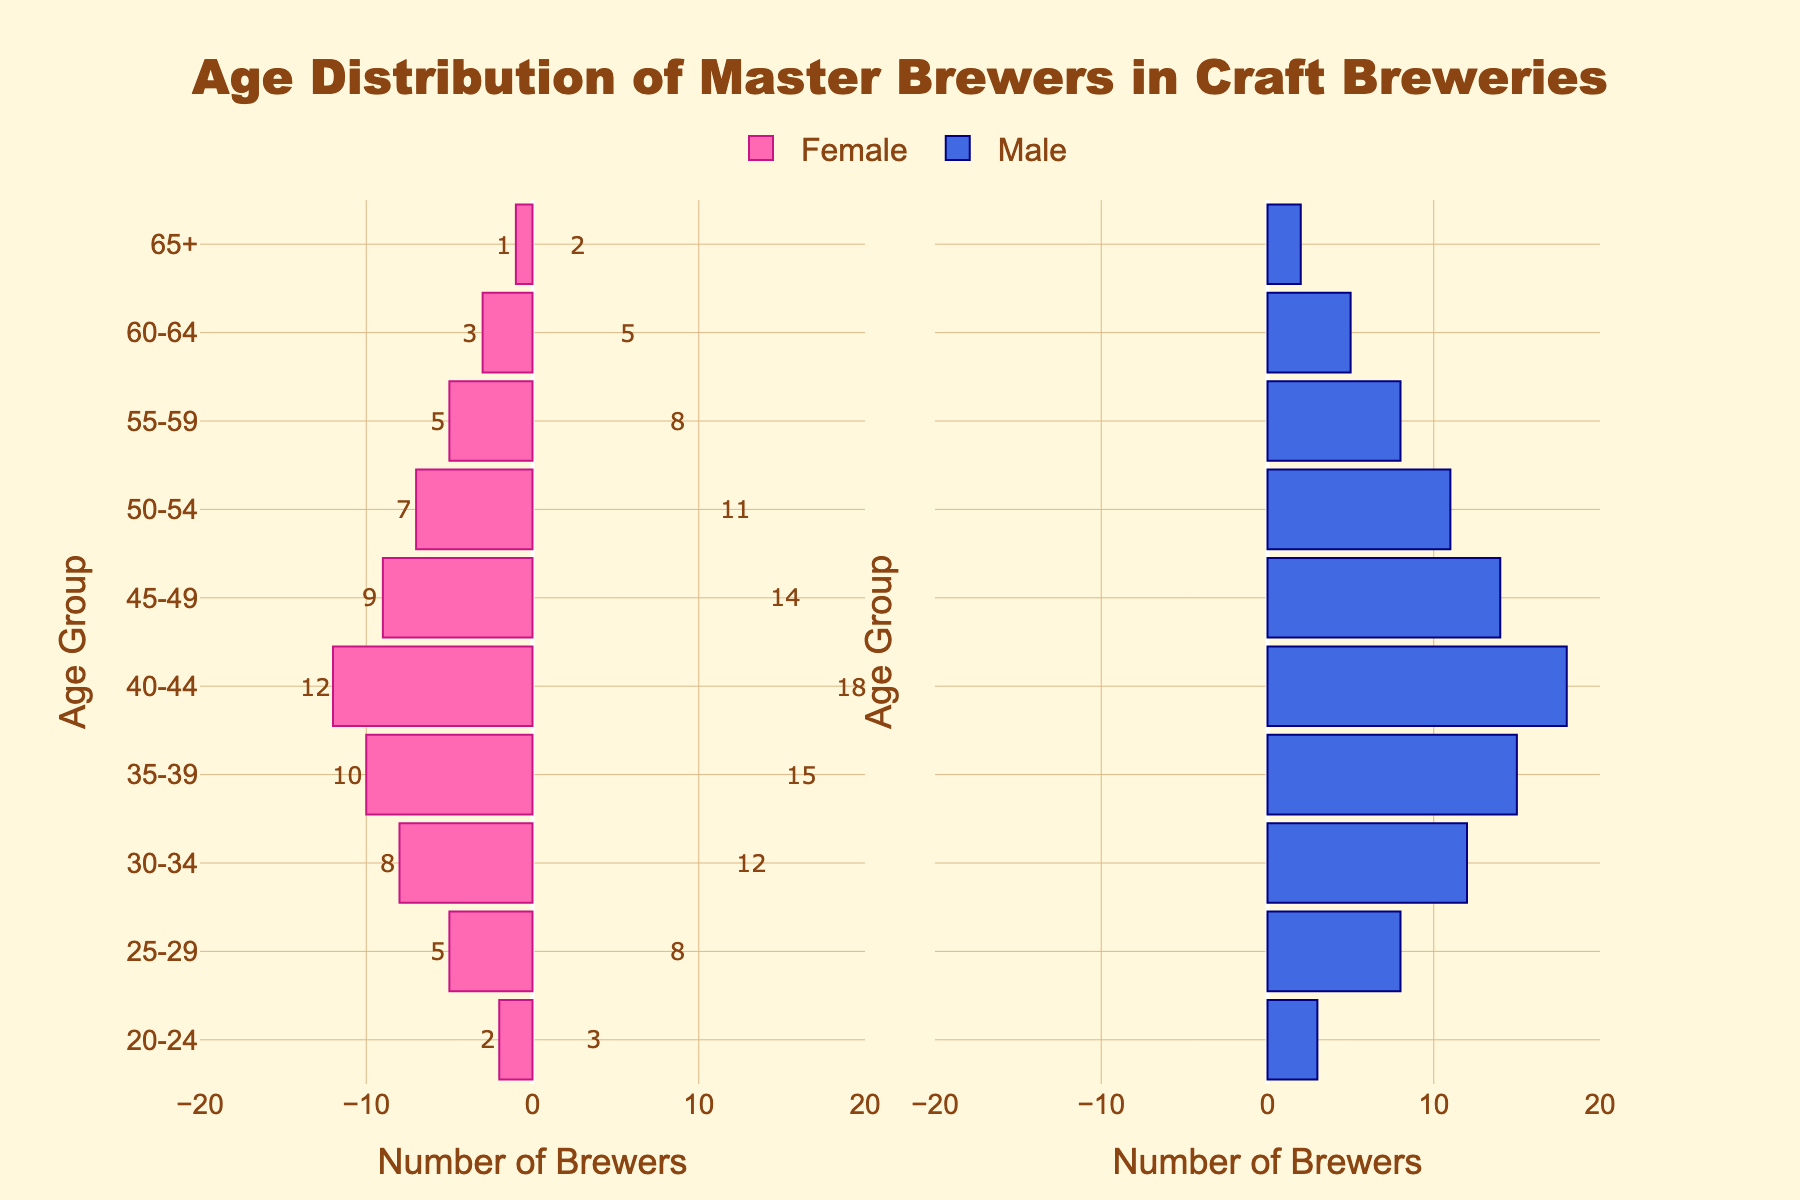How many female master brewers are there in the 40-44 age group? Look at the bar labeled "40-44" on the left (female) side of the pyramid. The length of the bar signifies the number of female brewers in this age group.
Answer: 12 Which age group has the highest number of male master brewers? Compare the lengths of the bars on the right (male) side of the pyramid. The longest bar will indicate the age group with the highest number of male brewers.
Answer: 40-44 What's the total number of master brewers aged 25-29? Add the number of female and male brewers for the age group "25-29". This can be done by summing up 5 (female) and 8 (male).
Answer: 13 Does the number of master brewers in the 65+ age group significantly deviate between males and females? Compare the lengths of the bars on the left (female) and right (male) side for the "65+" age group. The female bar represents 1 while the male bar represents 2, indicating a slight difference.
Answer: No Which gender has more master brewers in the 35-39 age group? Compare the lengths of the bars for the "35-39" age group on both sides of the pyramid. The female bar represents 10 while the male bar represents 15, indicating that there are more male brewers.
Answer: Male What is the combined number of master brewers in the 50-54 age group? Add the number of female and male brewers in the "50-54" age group. This can be calculated as 7 (female) + 11 (male) = 18.
Answer: 18 In which age group is the discrepancy between male and female master brewers the largest? For each age group, calculate the absolute difference between the number of male and female brewers, then identify the largest difference. The difference is largest in the 40-44 group with 6 brewers (18 - 12).
Answer: 40-44 How does the number of male master brewers aged 60-64 compare to those aged 55-59? Compare the lengths of the bars on the right side of the pyramid for the "60-64" and "55-59" age groups. The "60-64" group has 5 male brewers, while the "55-59" group has 8 male brewers, indicating fewer in the "60-64" group.
Answer: Fewer What age group has the smallest number of female master brewers? Compare the lengths of the bars on the left side (female) of the pyramid. The shortest bar indicates the age group with the smallest number of female brewers, which for females is in the "65+" group.
Answer: 65+ What's the total number of master brewers in the 35-39 and 45-49 age groups combined? Sum the female and male brewers for both age groups. For "35-39", add 10 (female) and 15 (male). For "45-49", add 9 (female) and 14 (male). Then sum these totals: (10 + 15) + (9 + 14) = 48.
Answer: 48 